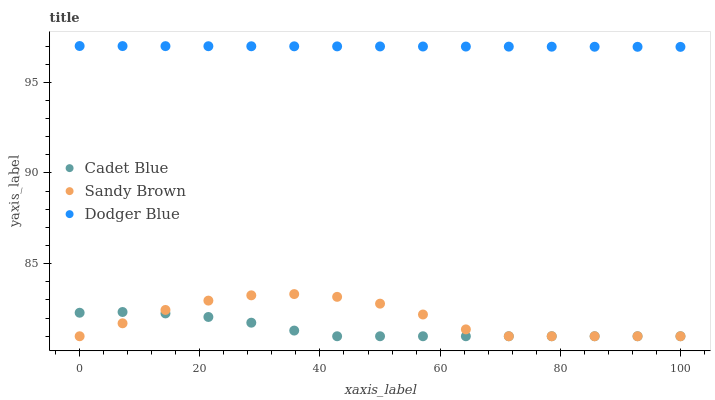Does Cadet Blue have the minimum area under the curve?
Answer yes or no. Yes. Does Dodger Blue have the maximum area under the curve?
Answer yes or no. Yes. Does Sandy Brown have the minimum area under the curve?
Answer yes or no. No. Does Sandy Brown have the maximum area under the curve?
Answer yes or no. No. Is Dodger Blue the smoothest?
Answer yes or no. Yes. Is Sandy Brown the roughest?
Answer yes or no. Yes. Is Cadet Blue the smoothest?
Answer yes or no. No. Is Cadet Blue the roughest?
Answer yes or no. No. Does Cadet Blue have the lowest value?
Answer yes or no. Yes. Does Dodger Blue have the highest value?
Answer yes or no. Yes. Does Sandy Brown have the highest value?
Answer yes or no. No. Is Sandy Brown less than Dodger Blue?
Answer yes or no. Yes. Is Dodger Blue greater than Sandy Brown?
Answer yes or no. Yes. Does Cadet Blue intersect Sandy Brown?
Answer yes or no. Yes. Is Cadet Blue less than Sandy Brown?
Answer yes or no. No. Is Cadet Blue greater than Sandy Brown?
Answer yes or no. No. Does Sandy Brown intersect Dodger Blue?
Answer yes or no. No. 